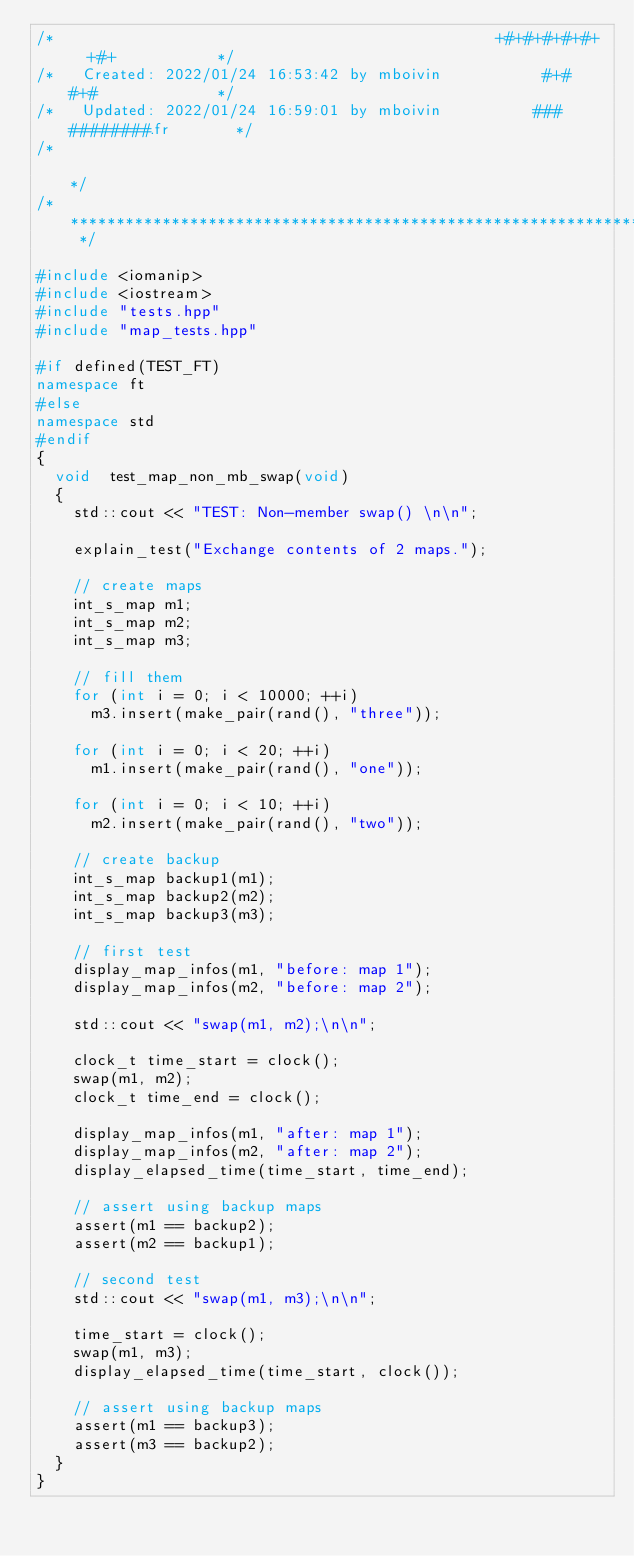<code> <loc_0><loc_0><loc_500><loc_500><_C++_>/*                                                +#+#+#+#+#+   +#+           */
/*   Created: 2022/01/24 16:53:42 by mboivin           #+#    #+#             */
/*   Updated: 2022/01/24 16:59:01 by mboivin          ###   ########.fr       */
/*                                                                            */
/* ************************************************************************** */

#include <iomanip>
#include <iostream>
#include "tests.hpp"
#include "map_tests.hpp"

#if defined(TEST_FT)
namespace ft
#else
namespace std
#endif
{
	void	test_map_non_mb_swap(void)
	{
		std::cout << "TEST: Non-member swap() \n\n";

		explain_test("Exchange contents of 2 maps.");

		// create maps
		int_s_map	m1;
		int_s_map	m2;
		int_s_map	m3;

		// fill them
		for (int i = 0; i < 10000; ++i)
			m3.insert(make_pair(rand(), "three"));

		for (int i = 0; i < 20; ++i)
			m1.insert(make_pair(rand(), "one"));

		for (int i = 0; i < 10; ++i)
			m2.insert(make_pair(rand(), "two"));

		// create backup
		int_s_map	backup1(m1);
		int_s_map	backup2(m2);
		int_s_map	backup3(m3);

		// first test
		display_map_infos(m1, "before: map 1");
		display_map_infos(m2, "before: map 2");

		std::cout << "swap(m1, m2);\n\n";

		clock_t	time_start = clock();
		swap(m1, m2);
		clock_t	time_end = clock();

		display_map_infos(m1, "after: map 1");
		display_map_infos(m2, "after: map 2");
		display_elapsed_time(time_start, time_end);

		// assert using backup maps
		assert(m1 == backup2);
		assert(m2 == backup1);

		// second test
		std::cout << "swap(m1, m3);\n\n";

		time_start = clock();
		swap(m1, m3);
		display_elapsed_time(time_start, clock());

		// assert using backup maps
		assert(m1 == backup3);
		assert(m3 == backup2);
	}
}
</code> 